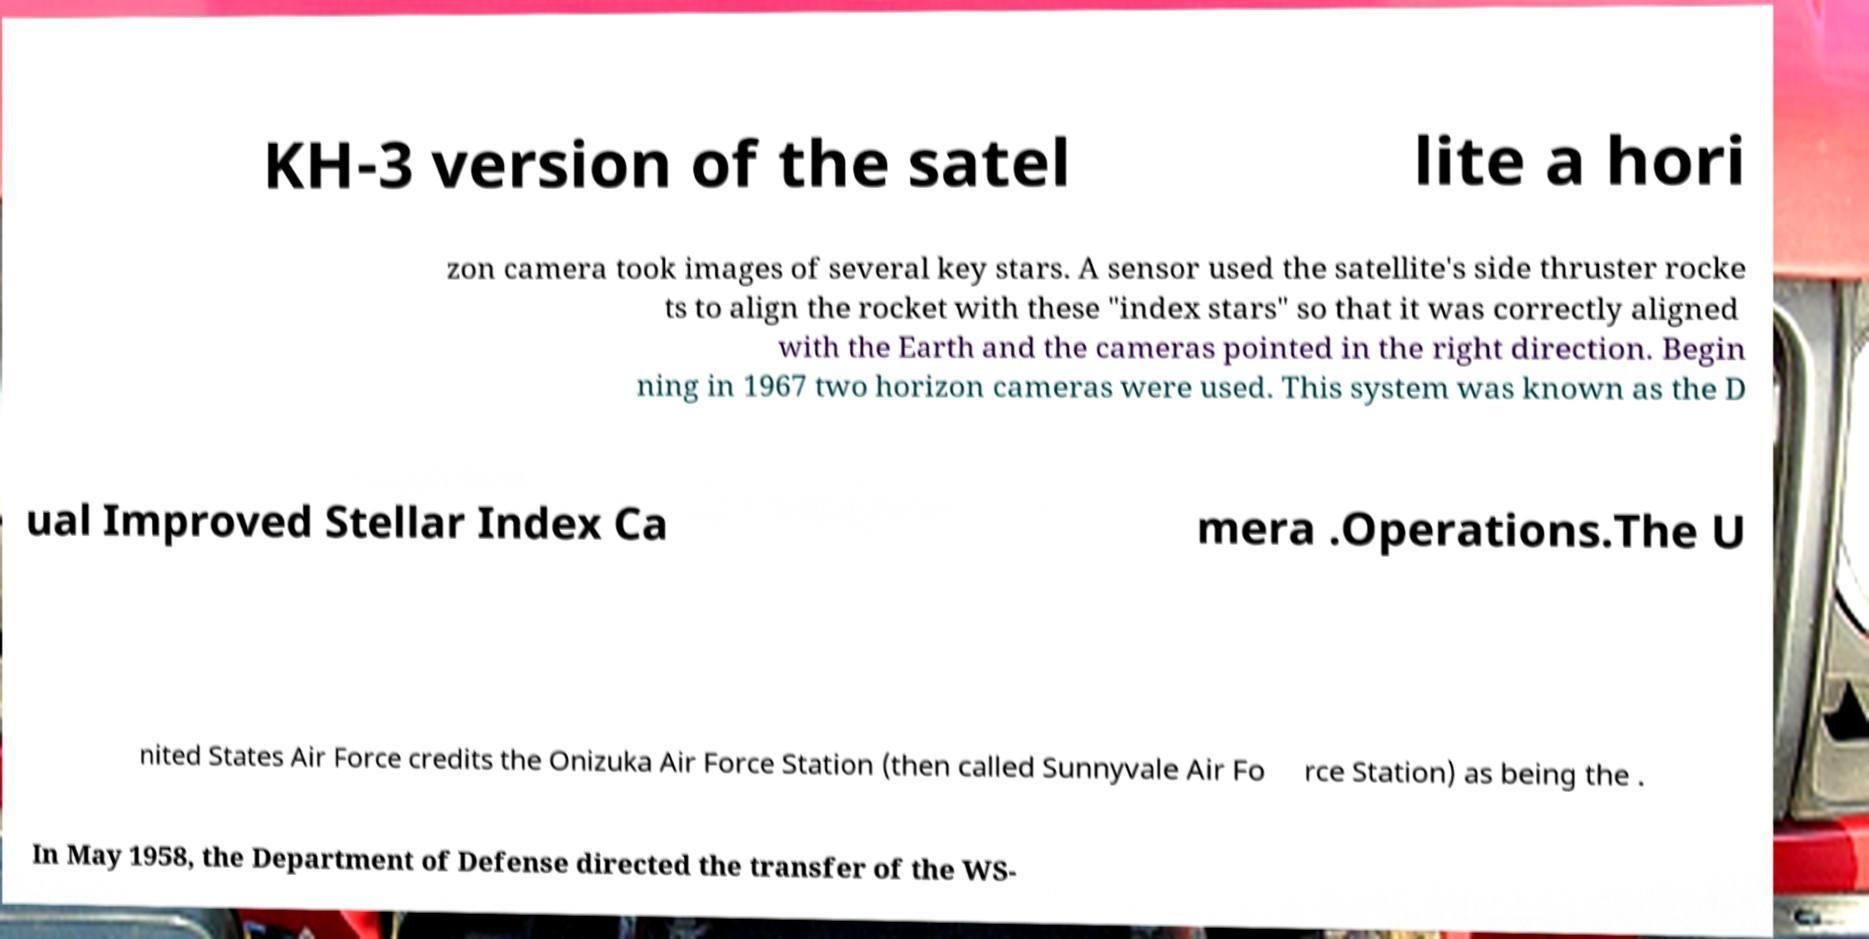Please read and relay the text visible in this image. What does it say? KH-3 version of the satel lite a hori zon camera took images of several key stars. A sensor used the satellite's side thruster rocke ts to align the rocket with these "index stars" so that it was correctly aligned with the Earth and the cameras pointed in the right direction. Begin ning in 1967 two horizon cameras were used. This system was known as the D ual Improved Stellar Index Ca mera .Operations.The U nited States Air Force credits the Onizuka Air Force Station (then called Sunnyvale Air Fo rce Station) as being the . In May 1958, the Department of Defense directed the transfer of the WS- 